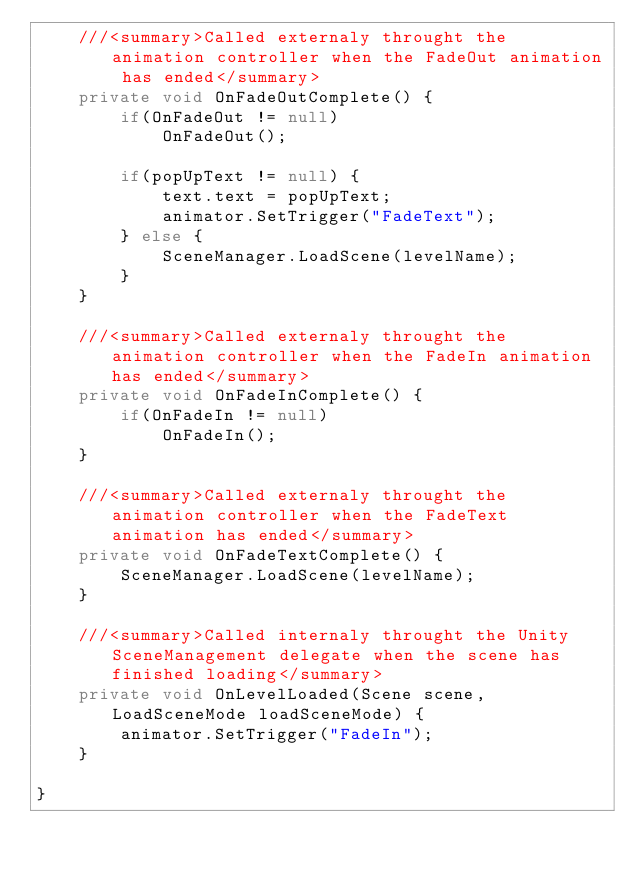<code> <loc_0><loc_0><loc_500><loc_500><_C#_>    ///<summary>Called externaly throught the animation controller when the FadeOut animation has ended</summary>
    private void OnFadeOutComplete() {
		if(OnFadeOut != null)
			OnFadeOut();

		if(popUpText != null) {
			text.text = popUpText;
			animator.SetTrigger("FadeText");
		} else {
			SceneManager.LoadScene(levelName);
		}
	}

	///<summary>Called externaly throught the animation controller when the FadeIn animation has ended</summary>
	private void OnFadeInComplete() {
		if(OnFadeIn != null)
			OnFadeIn();
	}

	///<summary>Called externaly throught the animation controller when the FadeText animation has ended</summary>
	private void OnFadeTextComplete() {
		SceneManager.LoadScene(levelName);
	}

	///<summary>Called internaly throught the Unity SceneManagement delegate when the scene has finished loading</summary>
	private void OnLevelLoaded(Scene scene, LoadSceneMode loadSceneMode) {
		animator.SetTrigger("FadeIn");
	}

}</code> 